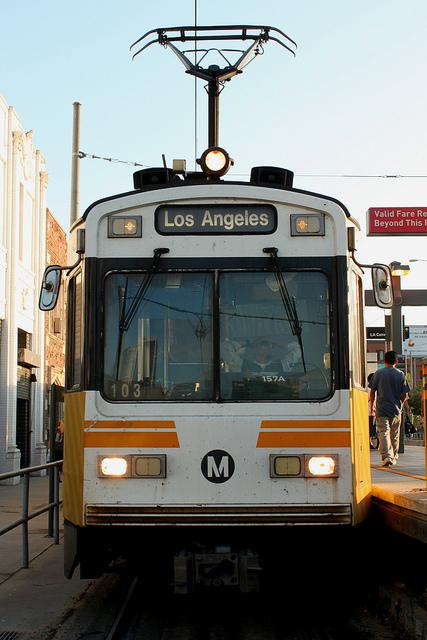Where is the bus going?
Short answer required. Los angeles. How is this bus powered?
Answer briefly. Electricity. Are the headlights on the train on?
Keep it brief. Yes. 